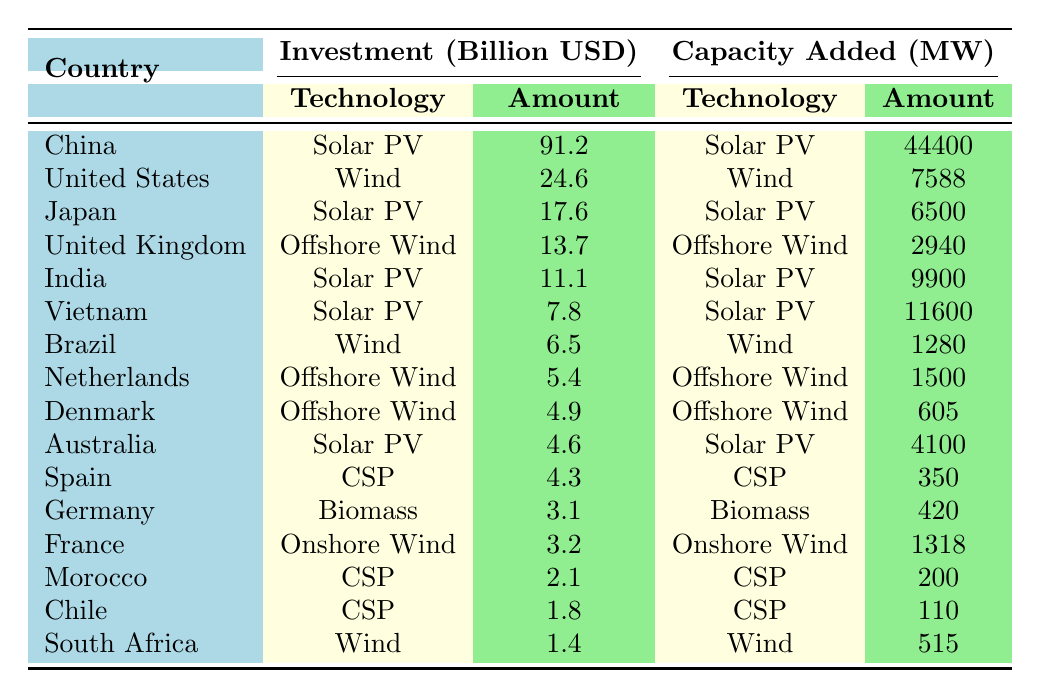What country had the highest investment in Solar PV in 2018? Referring to the table, China is listed under the Solar PV technology for 2018 with an investment of 91.2 billion USD, which is the highest among all listed countries for that year.
Answer: China Which country invested in Offshore Wind and what was the amount? The table shows that the United Kingdom invested in Offshore Wind technology with an investment amount of 13.7 billion USD.
Answer: United Kingdom, 13.7 billion USD What is the total investment in Solar PV across all countries for 2019? From the table, we have three countries listed under Solar PV for 2019: India with 11.1 billion USD, and Vietnam with 7.8 billion USD. The total investment is 11.1 + 7.8 = 18.9 billion USD.
Answer: 18.9 billion USD Did Germany invest in any Solar PV technology according to the table? The table does not list Germany under Solar PV technology; it shows Germany investing in Biomass technology instead. Thus, the answer is no.
Answer: No Which technology type had the least amount of investment in 2021 and what was the investment amount? According to the table, the technology with the least investment in 2021 was Concentrated Solar Power (CSP) with an investment of 1.8 billion USD by Chile. This is comparing all technologies listed under that year.
Answer: Concentrated Solar Power, 1.8 billion USD What is the average investment in Wind technology across the years represented in the table? The table shows investments for Wind technology: 24.6 billion USD (United States, 2018), 6.5 billion USD (Brazil, 2019), 1.4 billion USD (South Africa, 2021). Summing those gives 24.6 + 6.5 + 1.4 = 32.5 billion USD. There are three entries, so the average is 32.5 / 3 ≈ 10.83 billion USD.
Answer: 10.83 billion USD How much capacity was added in 2020 across all technologies? The table lists the following capacity added for 2020: 4100 MW (Australia, Solar PV), 2940 MW (United Kingdom, Offshore Wind), 1318 MW (France, Onshore Wind), and 200 MW (Morocco, CSP). Summing these values gives 4100 + 2940 + 1318 + 200 = 8558 MW.
Answer: 8558 MW In 2019, which country had the highest investment in any technology, and how much was it? The highest investment in 2019 was from India, which invested 11.1 billion USD in Solar PV. Comparatively, the other technologies and countries listed for that year had lower amounts.
Answer: India, 11.1 billion USD Was there any investment in Biomass technology in 2020? According to the table, there is no mention of any investments in Biomass technology for 2020, as it only lists investments for Solar PV, Offshore Wind, Onshore Wind, and CSP.
Answer: No 